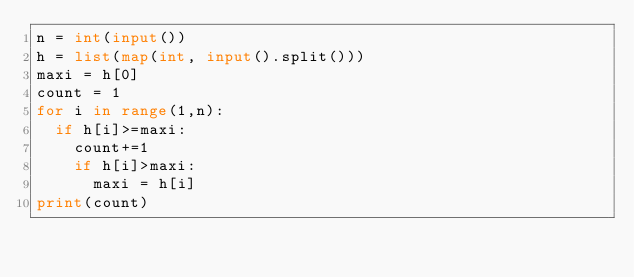<code> <loc_0><loc_0><loc_500><loc_500><_Python_>n = int(input())
h = list(map(int, input().split()))
maxi = h[0]
count = 1
for i in range(1,n):
  if h[i]>=maxi:
    count+=1
    if h[i]>maxi:
      maxi = h[i]
print(count)</code> 